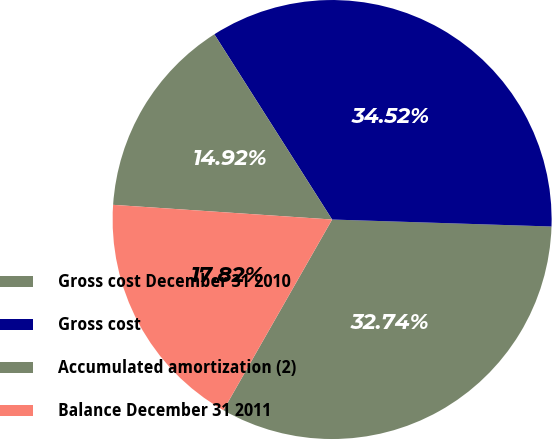Convert chart to OTSL. <chart><loc_0><loc_0><loc_500><loc_500><pie_chart><fcel>Gross cost December 31 2010<fcel>Gross cost<fcel>Accumulated amortization (2)<fcel>Balance December 31 2011<nl><fcel>32.74%<fcel>34.52%<fcel>14.92%<fcel>17.82%<nl></chart> 